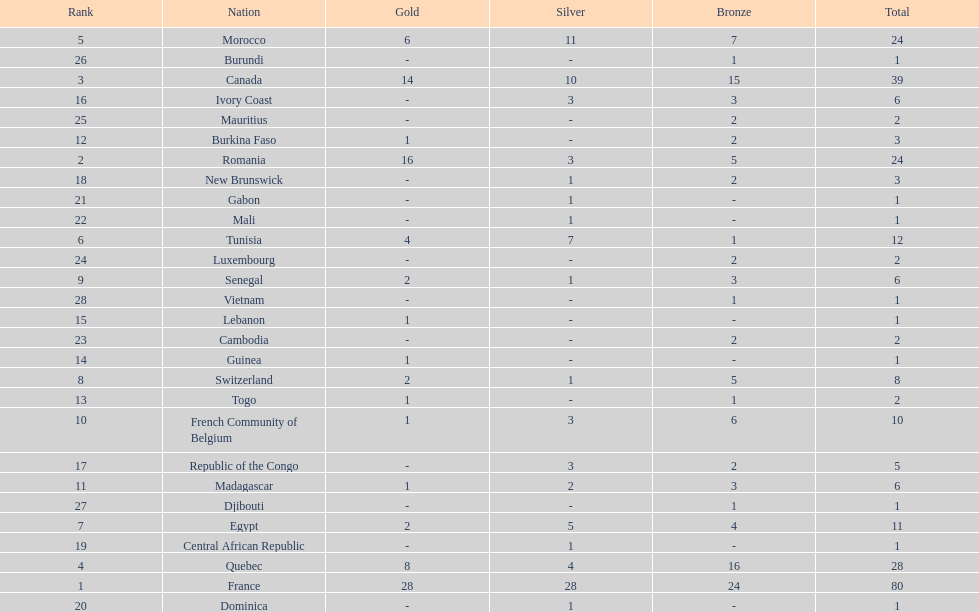How many counties have at least one silver medal? 18. 